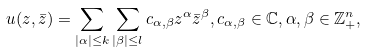Convert formula to latex. <formula><loc_0><loc_0><loc_500><loc_500>u ( z , \bar { z } ) = \sum _ { | \alpha | \leq k } \sum _ { | \beta | \leq l } c _ { \alpha , \beta } z ^ { \alpha } \bar { z } ^ { \beta } , c _ { \alpha , \beta } \in \mathbb { C } , \alpha , \beta \in \mathbb { Z } _ { + } ^ { n } ,</formula> 